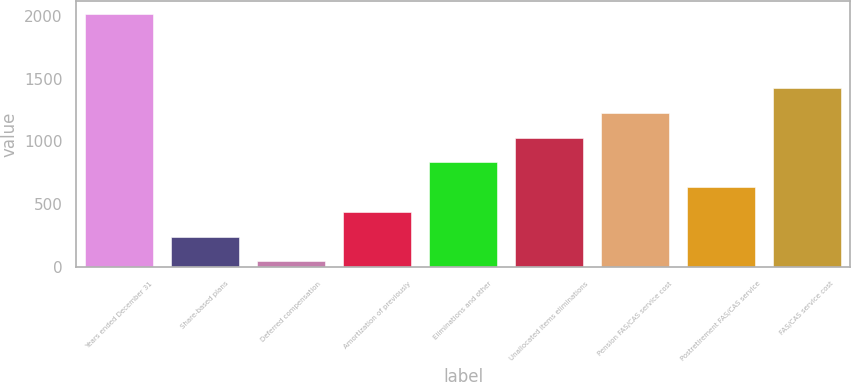Convert chart to OTSL. <chart><loc_0><loc_0><loc_500><loc_500><bar_chart><fcel>Years ended December 31<fcel>Share-based plans<fcel>Deferred compensation<fcel>Amortization of previously<fcel>Eliminations and other<fcel>Unallocated items eliminations<fcel>Pension FAS/CAS service cost<fcel>Postretirement FAS/CAS service<fcel>FAS/CAS service cost<nl><fcel>2016<fcel>243<fcel>46<fcel>440<fcel>834<fcel>1031<fcel>1228<fcel>637<fcel>1425<nl></chart> 